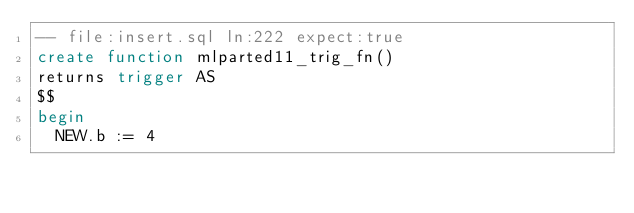Convert code to text. <code><loc_0><loc_0><loc_500><loc_500><_SQL_>-- file:insert.sql ln:222 expect:true
create function mlparted11_trig_fn()
returns trigger AS
$$
begin
  NEW.b := 4
</code> 